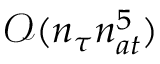<formula> <loc_0><loc_0><loc_500><loc_500>\mathcal { O } ( n _ { \tau } n _ { a t } ^ { 5 } )</formula> 